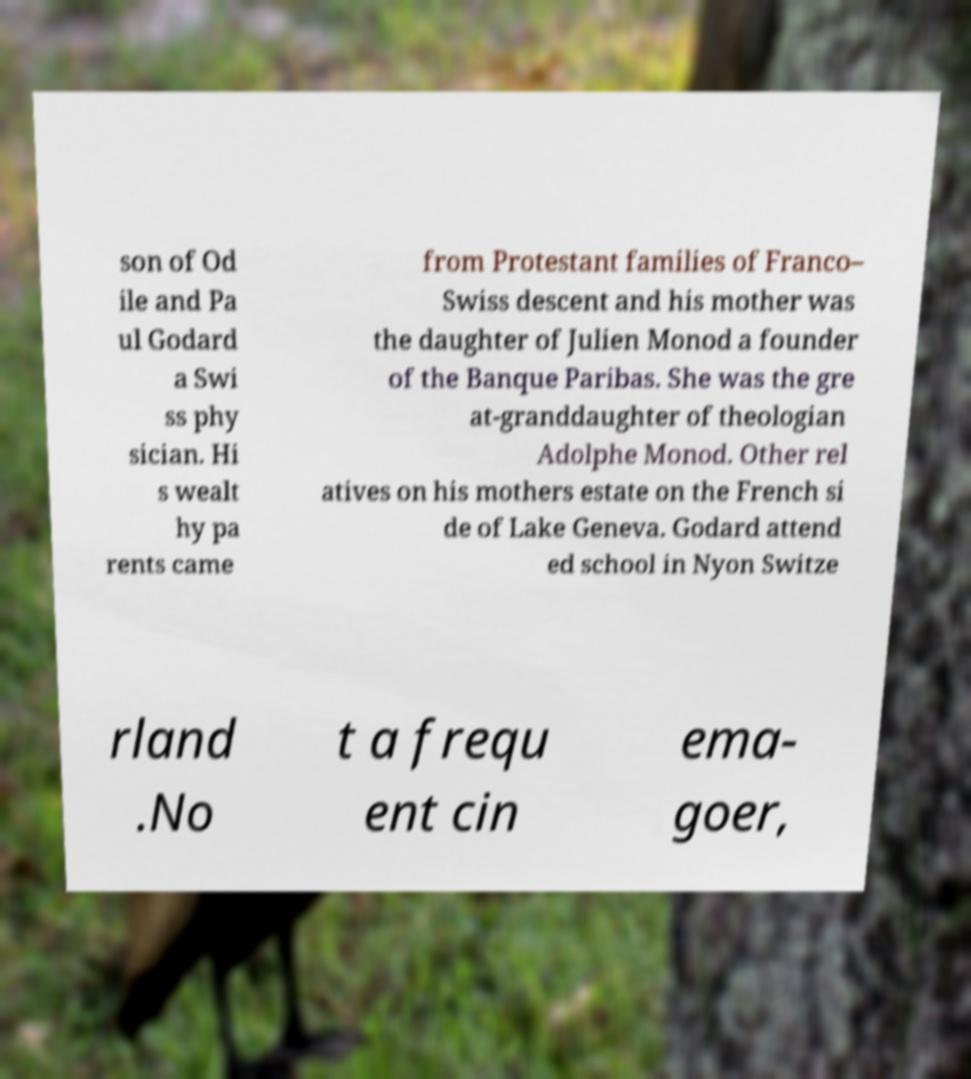There's text embedded in this image that I need extracted. Can you transcribe it verbatim? son of Od ile and Pa ul Godard a Swi ss phy sician. Hi s wealt hy pa rents came from Protestant families of Franco– Swiss descent and his mother was the daughter of Julien Monod a founder of the Banque Paribas. She was the gre at-granddaughter of theologian Adolphe Monod. Other rel atives on his mothers estate on the French si de of Lake Geneva. Godard attend ed school in Nyon Switze rland .No t a frequ ent cin ema- goer, 